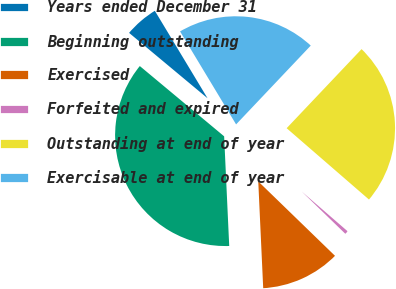Convert chart. <chart><loc_0><loc_0><loc_500><loc_500><pie_chart><fcel>Years ended December 31<fcel>Beginning outstanding<fcel>Exercised<fcel>Forfeited and expired<fcel>Outstanding at end of year<fcel>Exercisable at end of year<nl><fcel>5.31%<fcel>36.79%<fcel>12.01%<fcel>0.89%<fcel>24.29%<fcel>20.7%<nl></chart> 